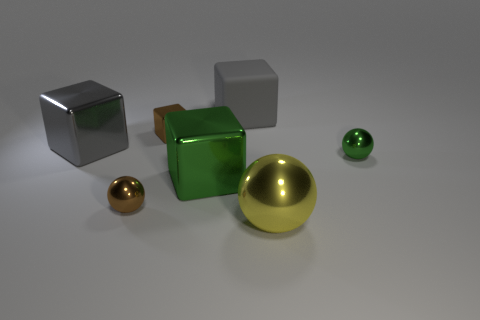Add 2 brown metallic spheres. How many objects exist? 9 Subtract all blocks. How many objects are left? 3 Add 2 large matte objects. How many large matte objects are left? 3 Add 5 large metal spheres. How many large metal spheres exist? 6 Subtract 0 gray cylinders. How many objects are left? 7 Subtract all small shiny balls. Subtract all big cyan cylinders. How many objects are left? 5 